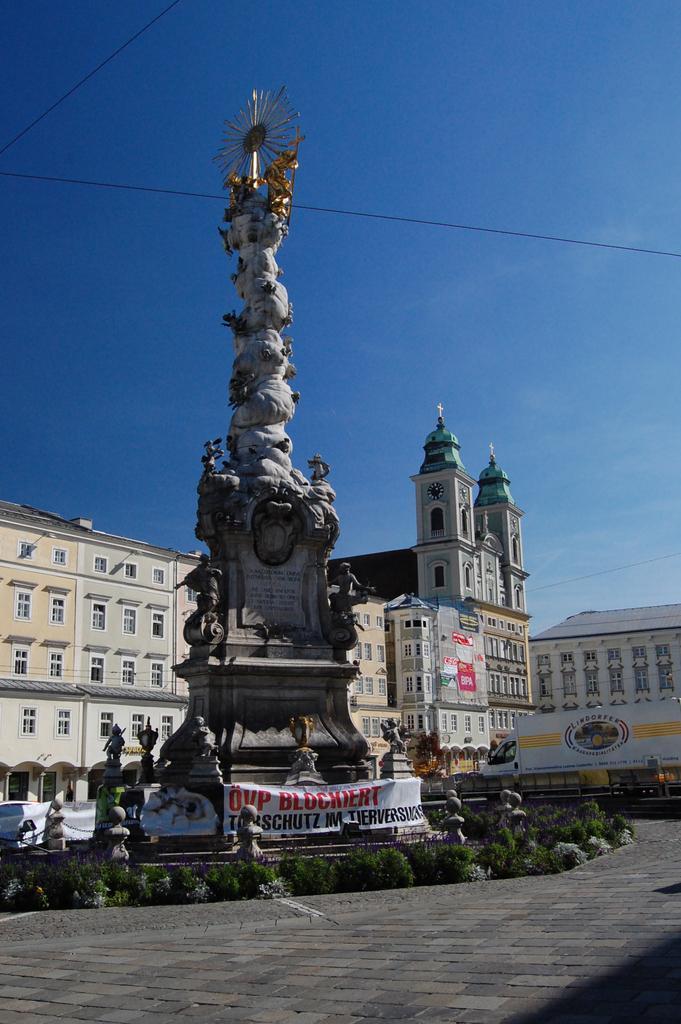Describe this image in one or two sentences. In the center of the image we can see a monument. In the background of the image we can see buildings, boards, bushes. At the top of the image there is a sky. At the bottom of the image there is a ground. 